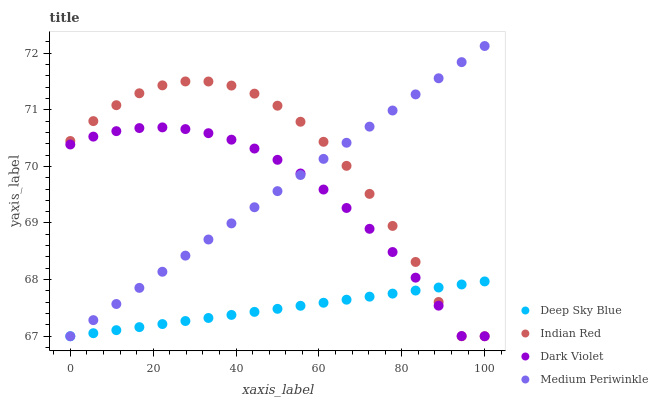Does Deep Sky Blue have the minimum area under the curve?
Answer yes or no. Yes. Does Indian Red have the maximum area under the curve?
Answer yes or no. Yes. Does Medium Periwinkle have the minimum area under the curve?
Answer yes or no. No. Does Medium Periwinkle have the maximum area under the curve?
Answer yes or no. No. Is Medium Periwinkle the smoothest?
Answer yes or no. Yes. Is Indian Red the roughest?
Answer yes or no. Yes. Is Indian Red the smoothest?
Answer yes or no. No. Is Medium Periwinkle the roughest?
Answer yes or no. No. Does Dark Violet have the lowest value?
Answer yes or no. Yes. Does Medium Periwinkle have the highest value?
Answer yes or no. Yes. Does Indian Red have the highest value?
Answer yes or no. No. Does Dark Violet intersect Medium Periwinkle?
Answer yes or no. Yes. Is Dark Violet less than Medium Periwinkle?
Answer yes or no. No. Is Dark Violet greater than Medium Periwinkle?
Answer yes or no. No. 